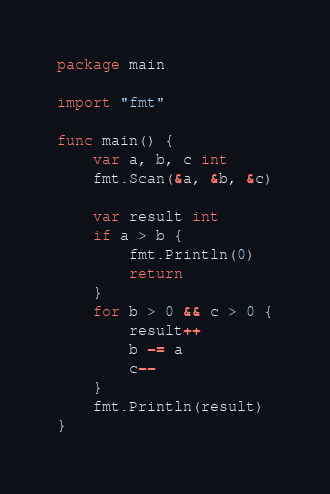Convert code to text. <code><loc_0><loc_0><loc_500><loc_500><_Go_>package main

import "fmt"

func main() {
	var a, b, c int
	fmt.Scan(&a, &b, &c)

	var result int
	if a > b {
		fmt.Println(0)
		return
	}
	for b > 0 && c > 0 {
		result++
		b -= a
		c--
	}
	fmt.Println(result)
}
</code> 